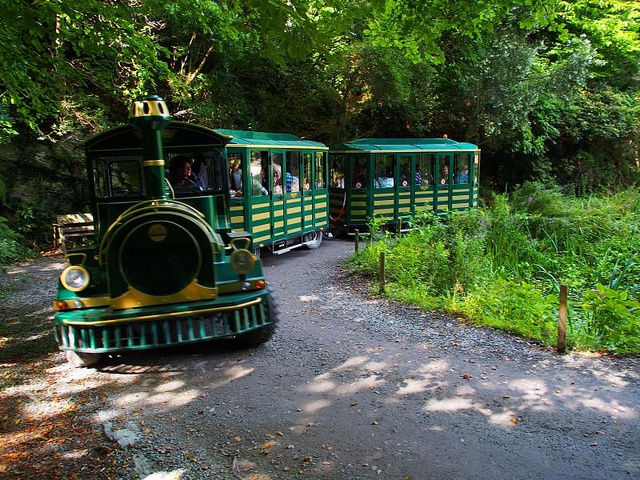Describe the objects in this image and their specific colors. I can see train in darkgreen, black, teal, and olive tones, people in darkgreen, black, maroon, and gray tones, people in darkgreen, black, maroon, and gray tones, people in darkgreen, black, teal, and gray tones, and people in darkgreen, black, gray, olive, and darkblue tones in this image. 